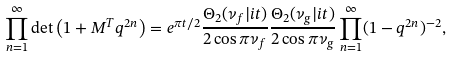Convert formula to latex. <formula><loc_0><loc_0><loc_500><loc_500>\prod _ { n = 1 } ^ { \infty } \det \left ( 1 + M ^ { T } q ^ { 2 n } \right ) = { e } ^ { \pi t / 2 } \frac { \Theta _ { 2 } ( \nu _ { f } | i t ) } { 2 \cos \pi \nu _ { f } } \frac { \Theta _ { 2 } ( \nu _ { g } | i t ) } { 2 \cos \pi \nu _ { g } } \prod _ { n = 1 } ^ { \infty } ( 1 - q ^ { 2 n } ) ^ { - 2 } ,</formula> 